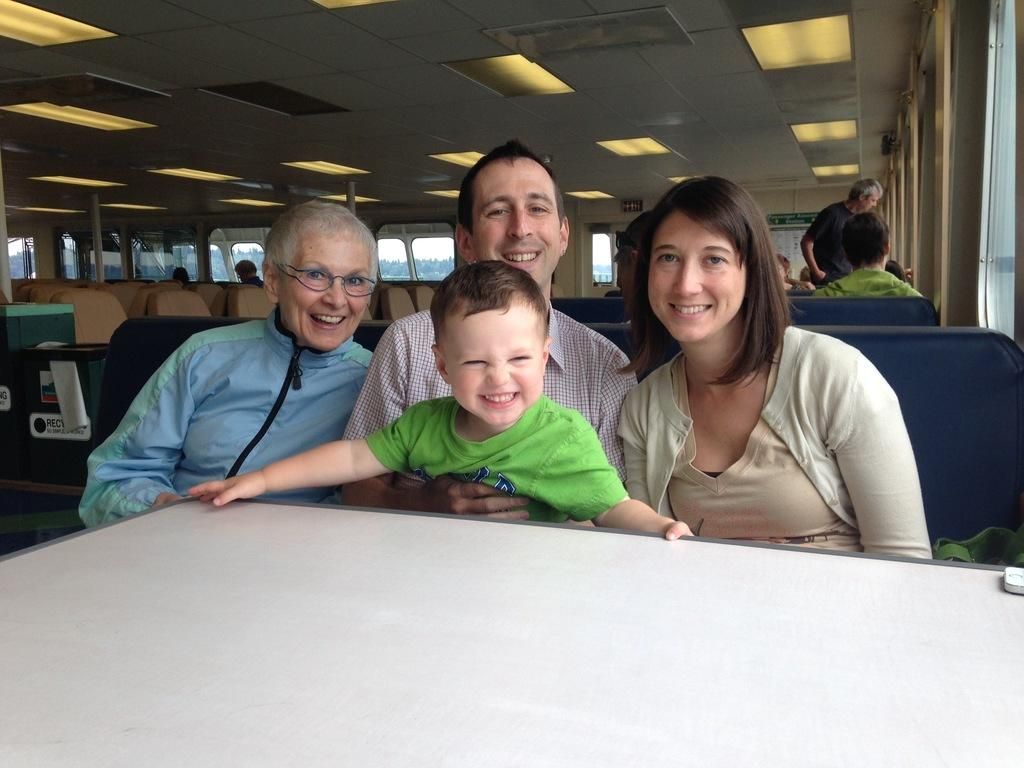How many people are in the image? There are four persons in the image. What is the facial expression of the persons in the image? The persons are smiling. What is located in front of the persons in the image? There is an empty table in front of the persons. What can be seen in the background of the image? There are windows, additional persons, and chairs in the background of the image. What type of trouble are the persons causing in the image? There is no indication of trouble or any negative actions in the image; the persons are smiling and there is an empty table in front of them. 